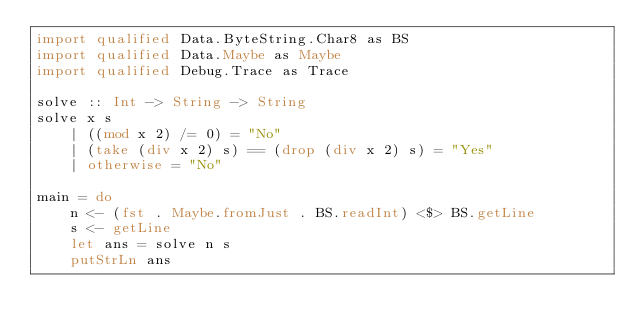Convert code to text. <code><loc_0><loc_0><loc_500><loc_500><_Haskell_>import qualified Data.ByteString.Char8 as BS
import qualified Data.Maybe as Maybe
import qualified Debug.Trace as Trace

solve :: Int -> String -> String
solve x s
    | ((mod x 2) /= 0) = "No"
    | (take (div x 2) s) == (drop (div x 2) s) = "Yes"
    | otherwise = "No"

main = do
    n <- (fst . Maybe.fromJust . BS.readInt) <$> BS.getLine
    s <- getLine
    let ans = solve n s
    putStrLn ans
</code> 